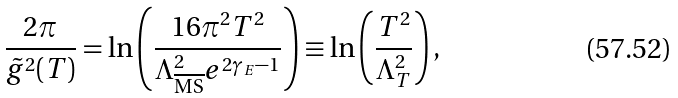Convert formula to latex. <formula><loc_0><loc_0><loc_500><loc_500>\frac { 2 \pi } { \tilde { g } ^ { 2 } ( T ) } = \ln { \left ( \frac { 1 6 \pi ^ { 2 } T ^ { 2 } } { \Lambda ^ { 2 } _ { \overline { \text {MS} } } e ^ { 2 \gamma _ { E } - 1 } } \right ) } \equiv \ln { \left ( \frac { T ^ { 2 } } { \Lambda ^ { 2 } _ { T } } \right ) } \, ,</formula> 